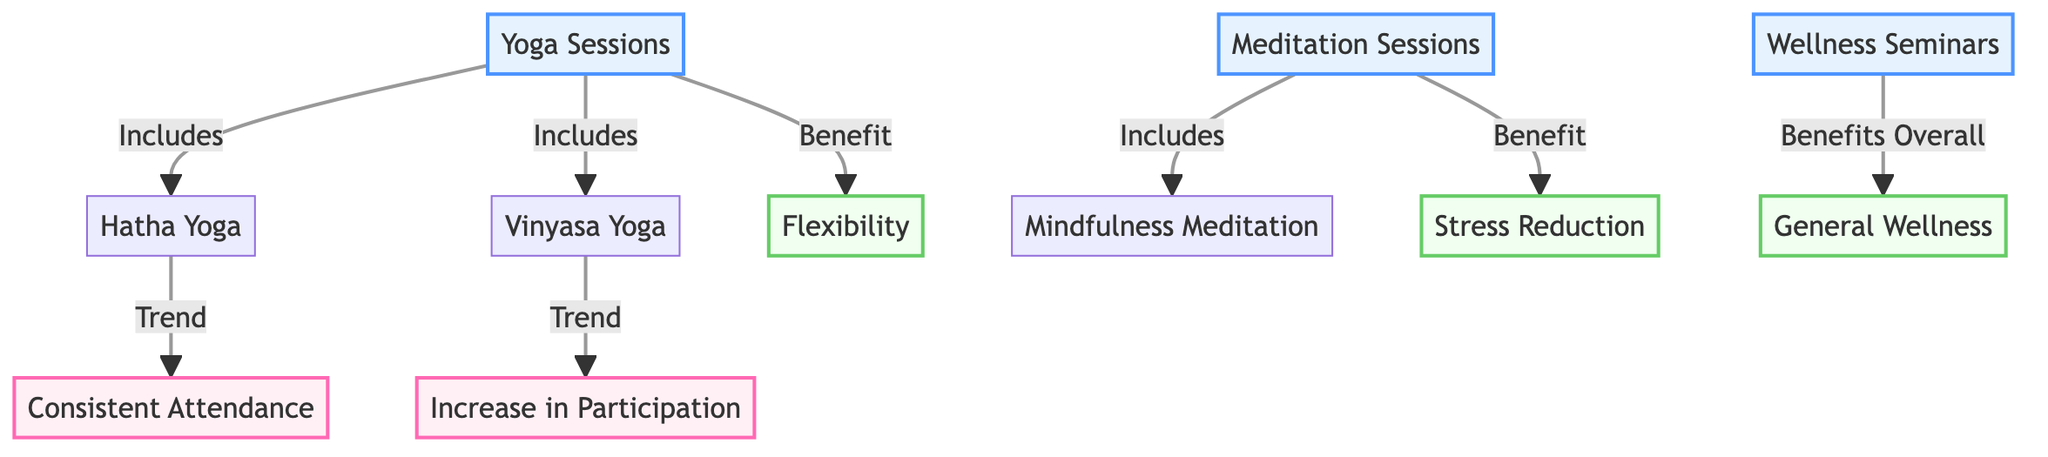What programs are included under yoga sessions? Looking at the diagram, "Yoga Sessions" has two arrows directing towards "Hatha Yoga" and "Vinyasa Yoga," indicating these two are included under yoga sessions.
Answer: Hatha Yoga, Vinyasa Yoga What is a benefit of meditation sessions? The diagram shows that there is an arrow connecting "Meditation Sessions" to "Stress Reduction," which indicates that stress reduction is a benefit provided by meditation.
Answer: Stress Reduction How many different wellness programs are depicted in the diagram? Counting the nodes under the program category, there are three nodes: "Yoga Sessions," "Meditation Sessions," and "Wellness Seminars."
Answer: 3 What trend is associated with vinyasa yoga? The diagram shows an arrow going from "Vinyasa Yoga" to "Increase in Participation," indicating that this trend is particularly associated with vinyasa yoga.
Answer: Increase in Participation What overall benefit do wellness seminars provide? The diagram connects "Wellness Seminars" with "General Wellness," indicating that the overall benefit of these seminars is general wellness.
Answer: General Wellness Is there a consistent trend associated with hatha yoga? Yes, the diagram connects "Hatha Yoga" with "Consistent Attendance," indicating a consistent trend related to hatha yoga.
Answer: Consistent Attendance What does the arrow from yoga sessions to flexibility signify? The arrow indicates that there is a direct relationship where flexibility is specifically listed as a benefit of yoga sessions.
Answer: Benefit What type of meditation session is included? The diagram specifies "Mindfulness Meditation" as included under the category of meditation sessions.
Answer: Mindfulness Meditation 